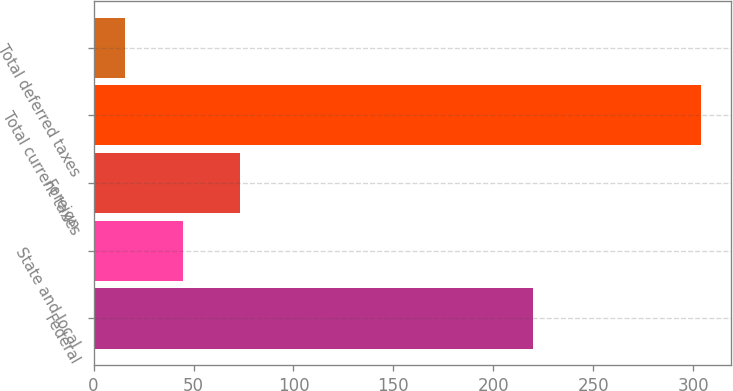Convert chart. <chart><loc_0><loc_0><loc_500><loc_500><bar_chart><fcel>Federal<fcel>State and local<fcel>Foreign<fcel>Total current taxes<fcel>Total deferred taxes<nl><fcel>219.6<fcel>44.69<fcel>73.48<fcel>303.8<fcel>15.9<nl></chart> 